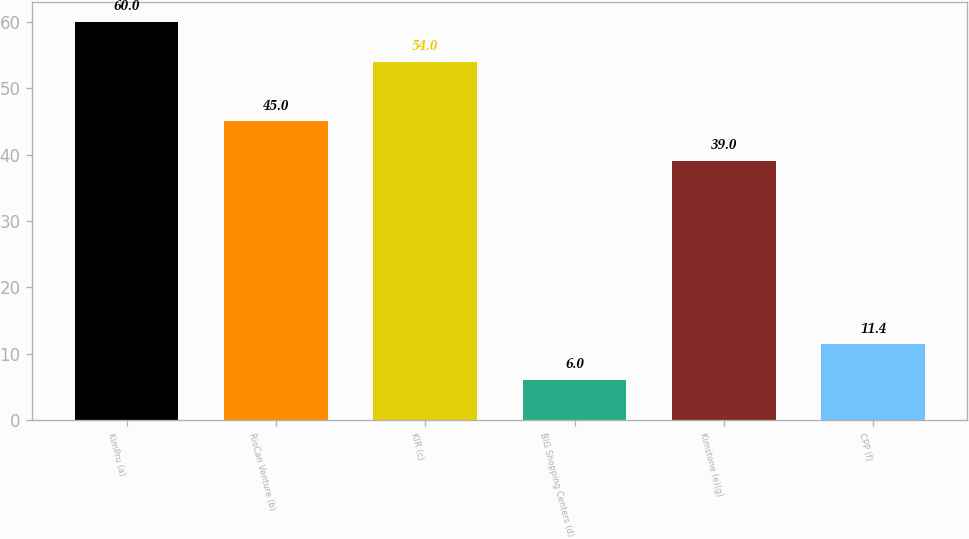Convert chart. <chart><loc_0><loc_0><loc_500><loc_500><bar_chart><fcel>KimPru (a)<fcel>RioCan Venture (b)<fcel>KIR (c)<fcel>BIG Shopping Centers (d)<fcel>Kimstone (e)(g)<fcel>CPP (f)<nl><fcel>60<fcel>45<fcel>54<fcel>6<fcel>39<fcel>11.4<nl></chart> 